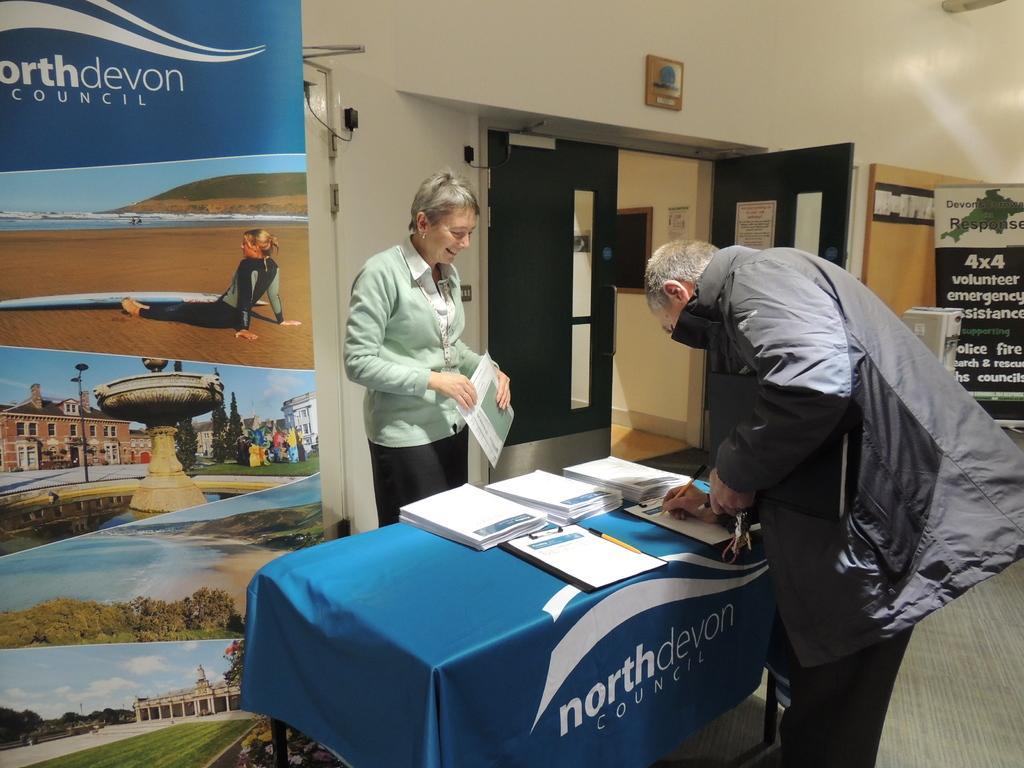Can you describe this image briefly? In this picture we can see two persons are standing, a person in the front is writing something, there is a table in the middle, we can see some papers and a pen on the table, on the right side and left side there are hoardings, we can see pictures of trees, grass, a water fountain, a building on this hoarding, we can see a wall and doors in the background. 